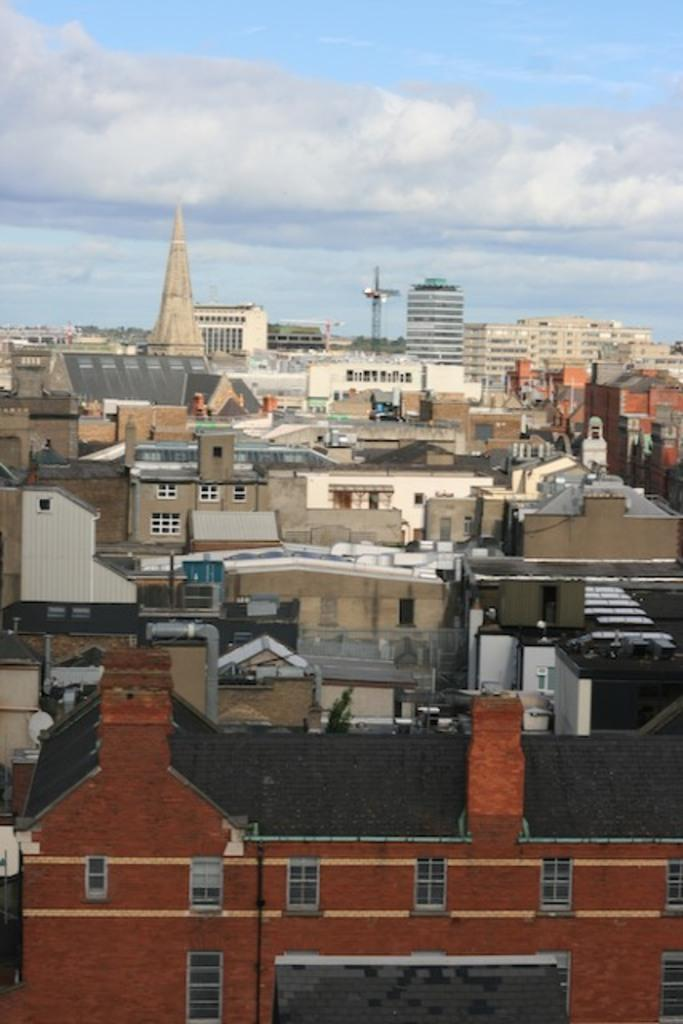What type of structures can be seen in the image? There are buildings with windows in the image. What other natural elements are present in the image? There are trees in the image. Can you describe any other objects in the image? There are some objects in the image, but their specific nature is not mentioned in the facts. What can be seen in the background of the image? The sky is visible in the background of the image. What is the condition of the sky in the image? Clouds are present in the sky. What riddle is being solved by the buildings in the image? There is no riddle being solved by the buildings in the image; they are simply structures with windows. What knowledge is being gained by the trees in the image? There is no knowledge being gained by the trees in the image; they are simply natural elements present in the scene. 